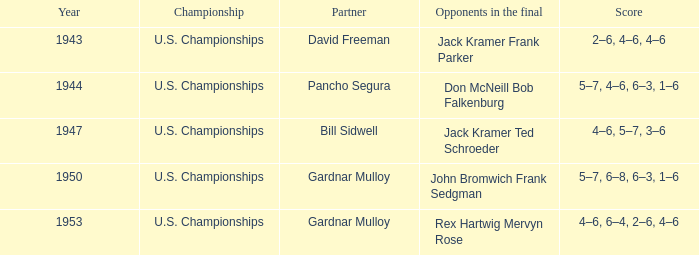Which Year has a Score of 5–7, 4–6, 6–3, 1–6? 1944.0. 